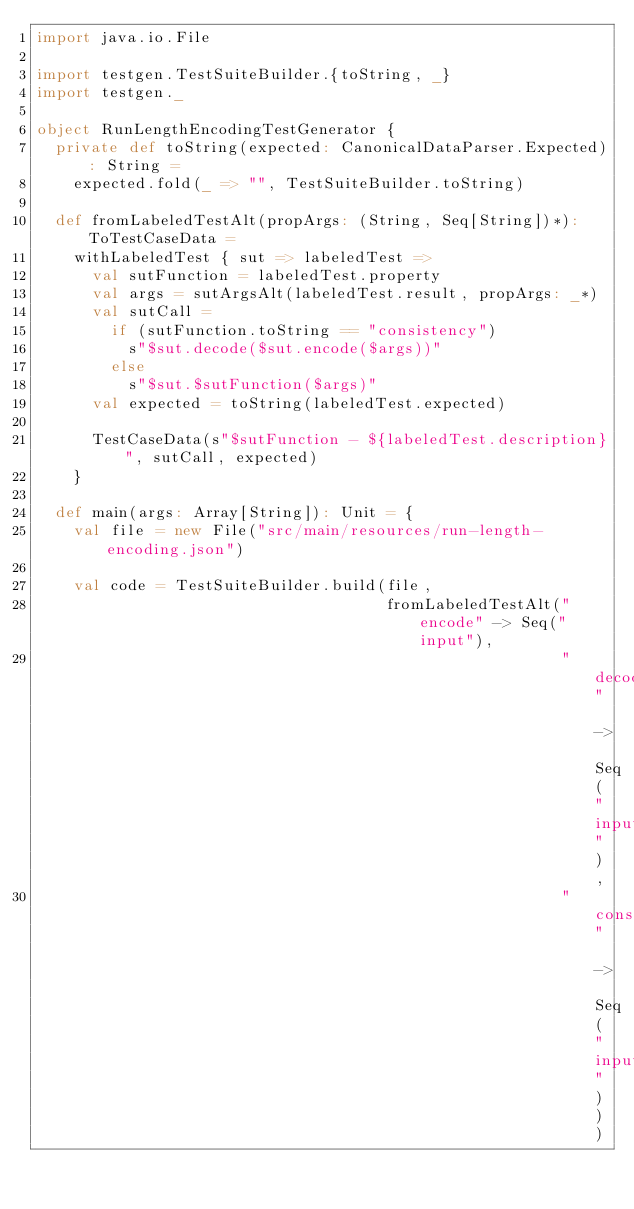Convert code to text. <code><loc_0><loc_0><loc_500><loc_500><_Scala_>import java.io.File

import testgen.TestSuiteBuilder.{toString, _}
import testgen._

object RunLengthEncodingTestGenerator {
  private def toString(expected: CanonicalDataParser.Expected): String =
    expected.fold(_ => "", TestSuiteBuilder.toString)

  def fromLabeledTestAlt(propArgs: (String, Seq[String])*): ToTestCaseData =
    withLabeledTest { sut => labeledTest =>
      val sutFunction = labeledTest.property
      val args = sutArgsAlt(labeledTest.result, propArgs: _*)
      val sutCall =
        if (sutFunction.toString == "consistency")
          s"$sut.decode($sut.encode($args))"
        else
          s"$sut.$sutFunction($args)"
      val expected = toString(labeledTest.expected)

      TestCaseData(s"$sutFunction - ${labeledTest.description}", sutCall, expected)
    }

  def main(args: Array[String]): Unit = {
    val file = new File("src/main/resources/run-length-encoding.json")

    val code = TestSuiteBuilder.build(file,
                                      fromLabeledTestAlt("encode" -> Seq("input"),
                                                         "decode" -> Seq("input"),
                                                         "consistency" -> Seq("input")))</code> 